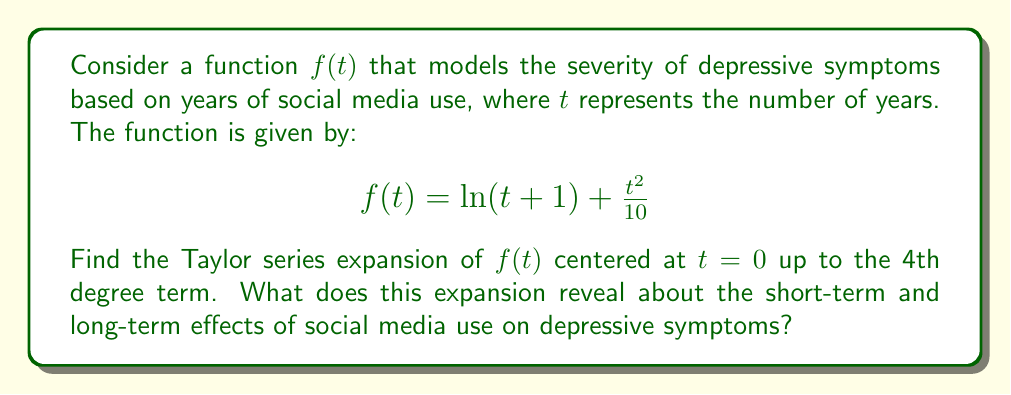What is the answer to this math problem? To find the Taylor series expansion of $f(t)$ centered at $t=0$ up to the 4th degree term, we need to calculate the derivatives of $f(t)$ up to the 4th order and evaluate them at $t=0$. The Taylor series formula is:

$$f(t) = f(0) + f'(0)t + \frac{f''(0)}{2!}t^2 + \frac{f'''(0)}{3!}t^3 + \frac{f^{(4)}(0)}{4!}t^4 + \cdots$$

Step 1: Calculate $f(0)$ and the derivatives
$f(0) = \ln(1) + \frac{0^2}{10} = 0$

$f'(t) = \frac{1}{t+1} + \frac{t}{5}$
$f'(0) = 1$

$f''(t) = -\frac{1}{(t+1)^2} + \frac{1}{5}$
$f''(0) = -1 + \frac{1}{5} = -\frac{4}{5}$

$f'''(t) = \frac{2}{(t+1)^3}$
$f'''(0) = 2$

$f^{(4)}(t) = -\frac{6}{(t+1)^4}$
$f^{(4)}(0) = -6$

Step 2: Substitute the values into the Taylor series formula

$$f(t) \approx 0 + t - \frac{4}{5}\frac{t^2}{2!} + 2\frac{t^3}{3!} - 6\frac{t^4}{4!}$$

Step 3: Simplify

$$f(t) \approx t - \frac{2}{5}t^2 + \frac{1}{3}t^3 - \frac{1}{4}t^4$$

This expansion reveals:
1. Short-term effects (linear term): Initially, depressive symptoms increase linearly with social media use.
2. Medium-term effects (quadratic term): There's a slight decrease in the rate of symptom increase.
3. Long-term effects (cubic and quartic terms): The rate of symptom increase accelerates again, suggesting potentially more severe long-term consequences.
Answer: $f(t) \approx t - \frac{2}{5}t^2 + \frac{1}{3}t^3 - \frac{1}{4}t^4$ 